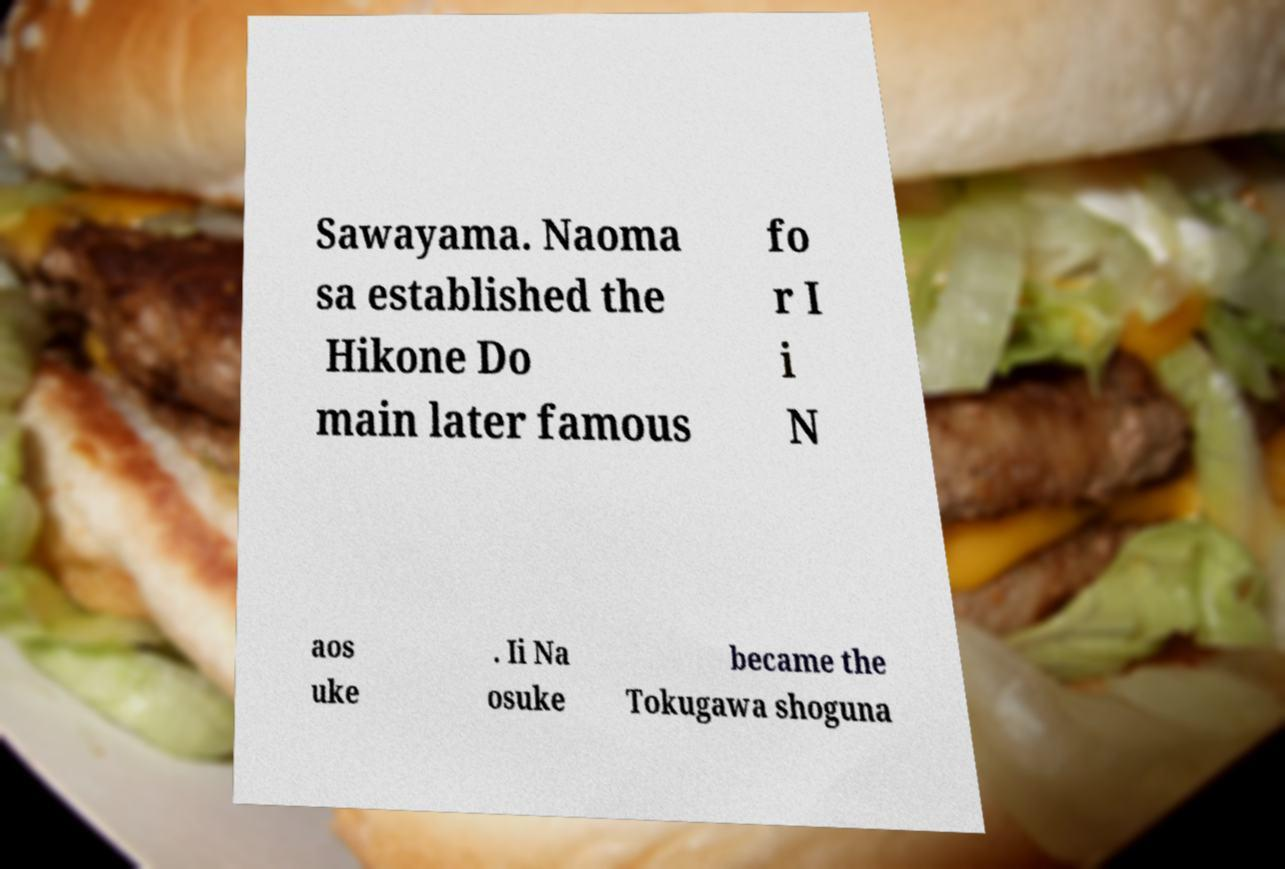Please identify and transcribe the text found in this image. Sawayama. Naoma sa established the Hikone Do main later famous fo r I i N aos uke . Ii Na osuke became the Tokugawa shoguna 